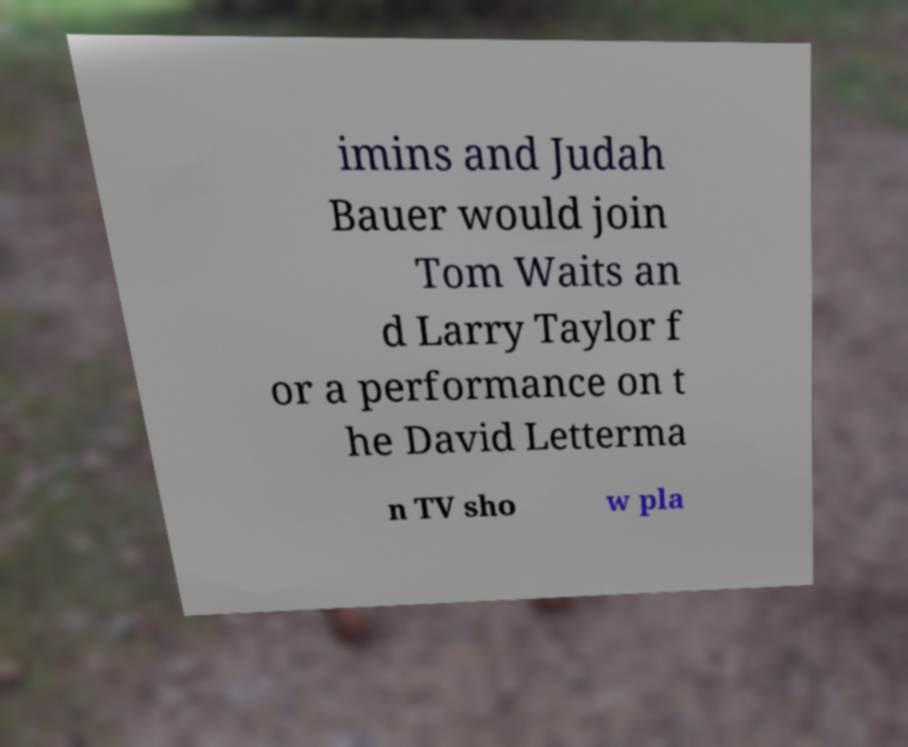There's text embedded in this image that I need extracted. Can you transcribe it verbatim? imins and Judah Bauer would join Tom Waits an d Larry Taylor f or a performance on t he David Letterma n TV sho w pla 